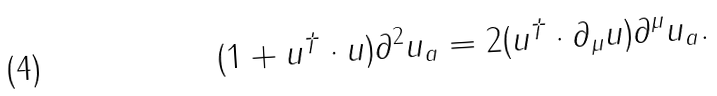<formula> <loc_0><loc_0><loc_500><loc_500>( 1 + u ^ { \dag } \cdot u ) \partial ^ { 2 } u _ { a } = 2 ( u ^ { \dag } \cdot \partial _ { \mu } u ) \partial ^ { \mu } u _ { a } .</formula> 